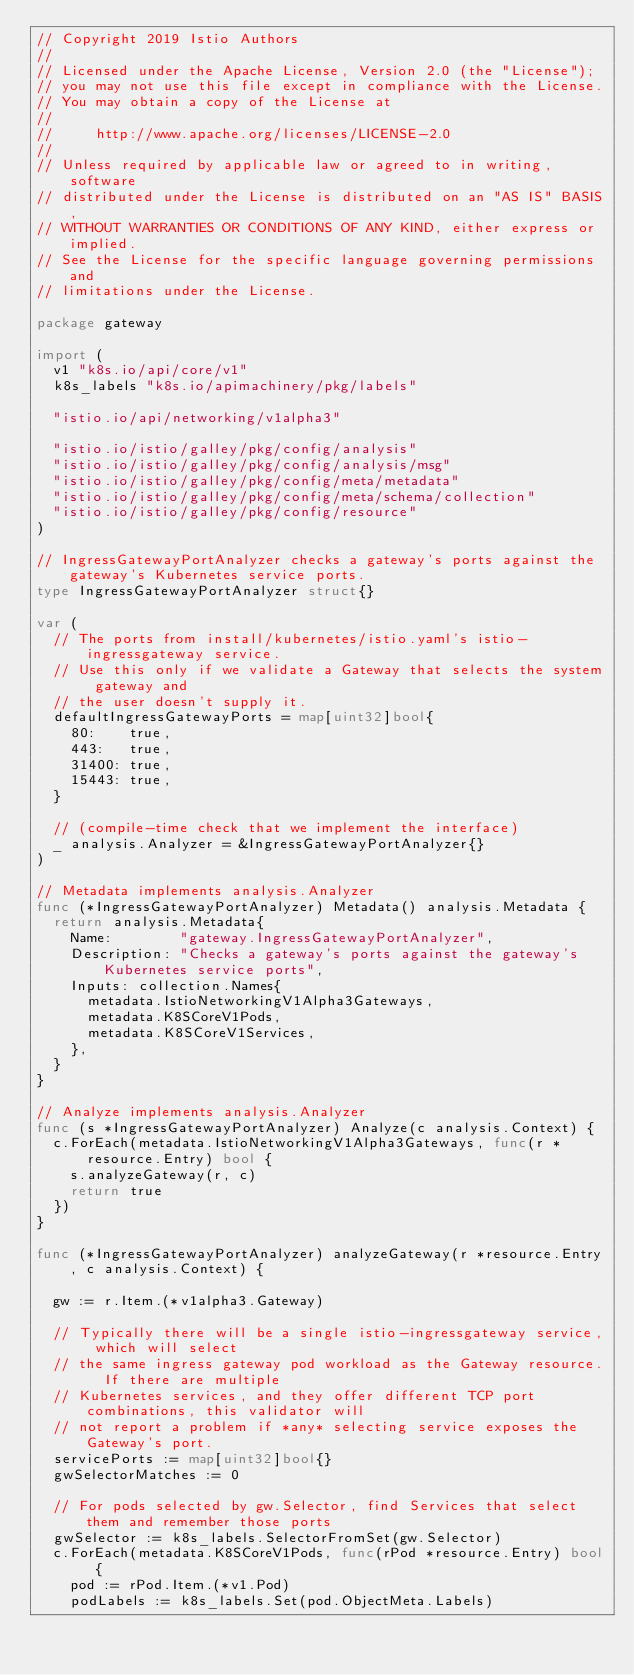Convert code to text. <code><loc_0><loc_0><loc_500><loc_500><_Go_>// Copyright 2019 Istio Authors
//
// Licensed under the Apache License, Version 2.0 (the "License");
// you may not use this file except in compliance with the License.
// You may obtain a copy of the License at
//
//     http://www.apache.org/licenses/LICENSE-2.0
//
// Unless required by applicable law or agreed to in writing, software
// distributed under the License is distributed on an "AS IS" BASIS,
// WITHOUT WARRANTIES OR CONDITIONS OF ANY KIND, either express or implied.
// See the License for the specific language governing permissions and
// limitations under the License.

package gateway

import (
	v1 "k8s.io/api/core/v1"
	k8s_labels "k8s.io/apimachinery/pkg/labels"

	"istio.io/api/networking/v1alpha3"

	"istio.io/istio/galley/pkg/config/analysis"
	"istio.io/istio/galley/pkg/config/analysis/msg"
	"istio.io/istio/galley/pkg/config/meta/metadata"
	"istio.io/istio/galley/pkg/config/meta/schema/collection"
	"istio.io/istio/galley/pkg/config/resource"
)

// IngressGatewayPortAnalyzer checks a gateway's ports against the gateway's Kubernetes service ports.
type IngressGatewayPortAnalyzer struct{}

var (
	// The ports from install/kubernetes/istio.yaml's istio-ingressgateway service.
	// Use this only if we validate a Gateway that selects the system gateway and
	// the user doesn't supply it.
	defaultIngressGatewayPorts = map[uint32]bool{
		80:    true,
		443:   true,
		31400: true,
		15443: true,
	}

	// (compile-time check that we implement the interface)
	_ analysis.Analyzer = &IngressGatewayPortAnalyzer{}
)

// Metadata implements analysis.Analyzer
func (*IngressGatewayPortAnalyzer) Metadata() analysis.Metadata {
	return analysis.Metadata{
		Name:        "gateway.IngressGatewayPortAnalyzer",
		Description: "Checks a gateway's ports against the gateway's Kubernetes service ports",
		Inputs: collection.Names{
			metadata.IstioNetworkingV1Alpha3Gateways,
			metadata.K8SCoreV1Pods,
			metadata.K8SCoreV1Services,
		},
	}
}

// Analyze implements analysis.Analyzer
func (s *IngressGatewayPortAnalyzer) Analyze(c analysis.Context) {
	c.ForEach(metadata.IstioNetworkingV1Alpha3Gateways, func(r *resource.Entry) bool {
		s.analyzeGateway(r, c)
		return true
	})
}

func (*IngressGatewayPortAnalyzer) analyzeGateway(r *resource.Entry, c analysis.Context) {

	gw := r.Item.(*v1alpha3.Gateway)

	// Typically there will be a single istio-ingressgateway service, which will select
	// the same ingress gateway pod workload as the Gateway resource.  If there are multiple
	// Kubernetes services, and they offer different TCP port combinations, this validator will
	// not report a problem if *any* selecting service exposes the Gateway's port.
	servicePorts := map[uint32]bool{}
	gwSelectorMatches := 0

	// For pods selected by gw.Selector, find Services that select them and remember those ports
	gwSelector := k8s_labels.SelectorFromSet(gw.Selector)
	c.ForEach(metadata.K8SCoreV1Pods, func(rPod *resource.Entry) bool {
		pod := rPod.Item.(*v1.Pod)
		podLabels := k8s_labels.Set(pod.ObjectMeta.Labels)</code> 